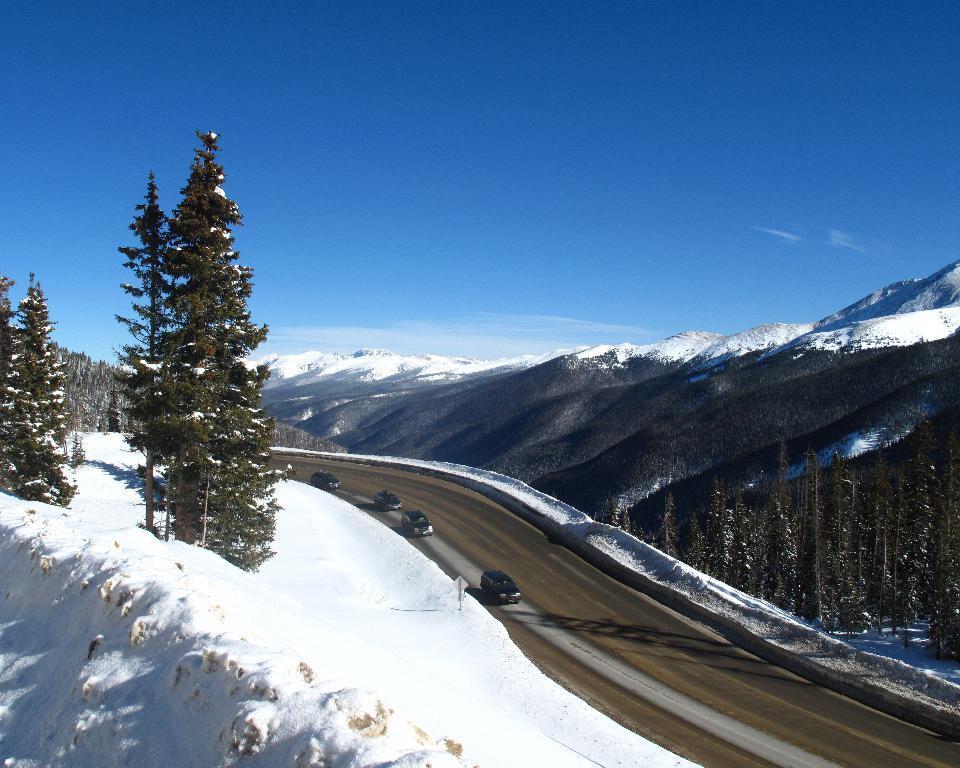In one or two sentences, can you explain what this image depicts? In this picture we can see four cars are traveling on the road, at the bottom there is snow, on the right side and left side we can see trees, there is the sky at the top of the picture. 